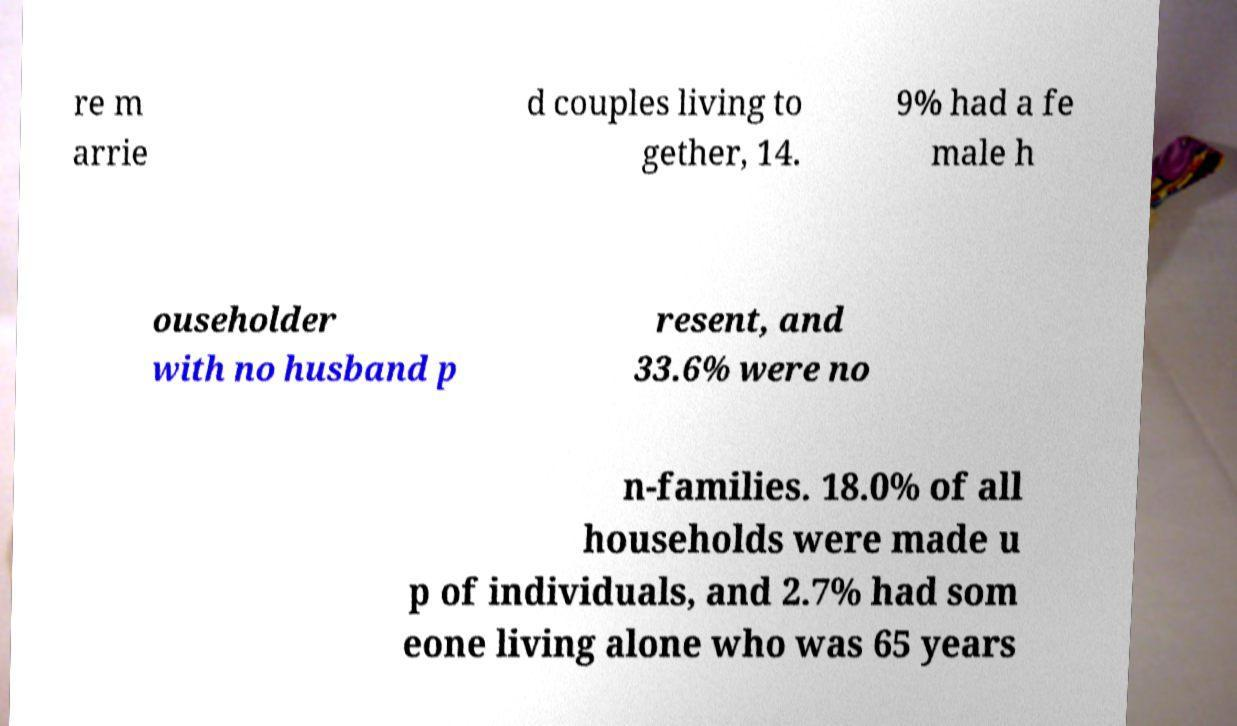For documentation purposes, I need the text within this image transcribed. Could you provide that? re m arrie d couples living to gether, 14. 9% had a fe male h ouseholder with no husband p resent, and 33.6% were no n-families. 18.0% of all households were made u p of individuals, and 2.7% had som eone living alone who was 65 years 